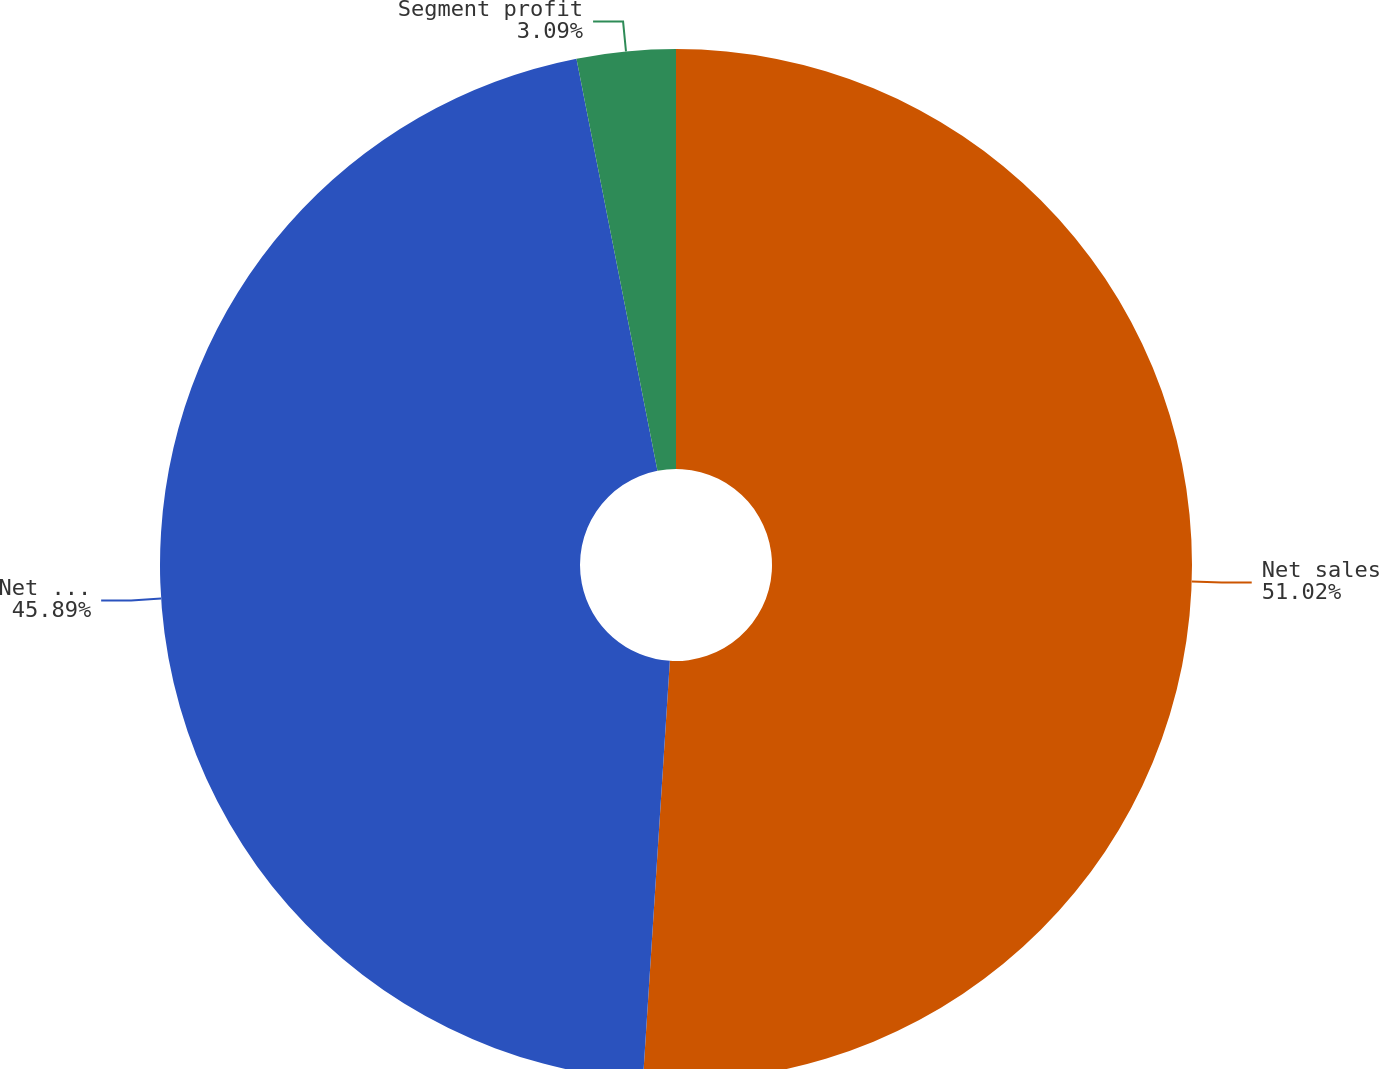Convert chart to OTSL. <chart><loc_0><loc_0><loc_500><loc_500><pie_chart><fcel>Net sales<fcel>Net sales to external<fcel>Segment profit<nl><fcel>51.02%<fcel>45.89%<fcel>3.09%<nl></chart> 